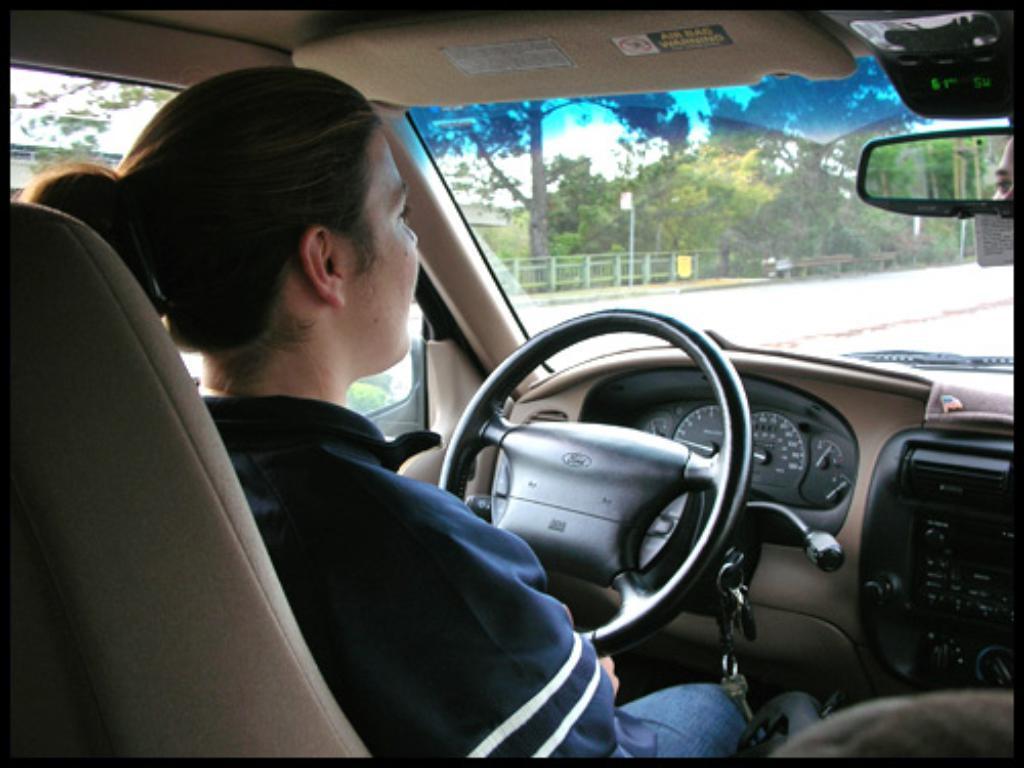Could you give a brief overview of what you see in this image? In this picture we can see a person inside the vehicle. This is mirror and these are the trees. 